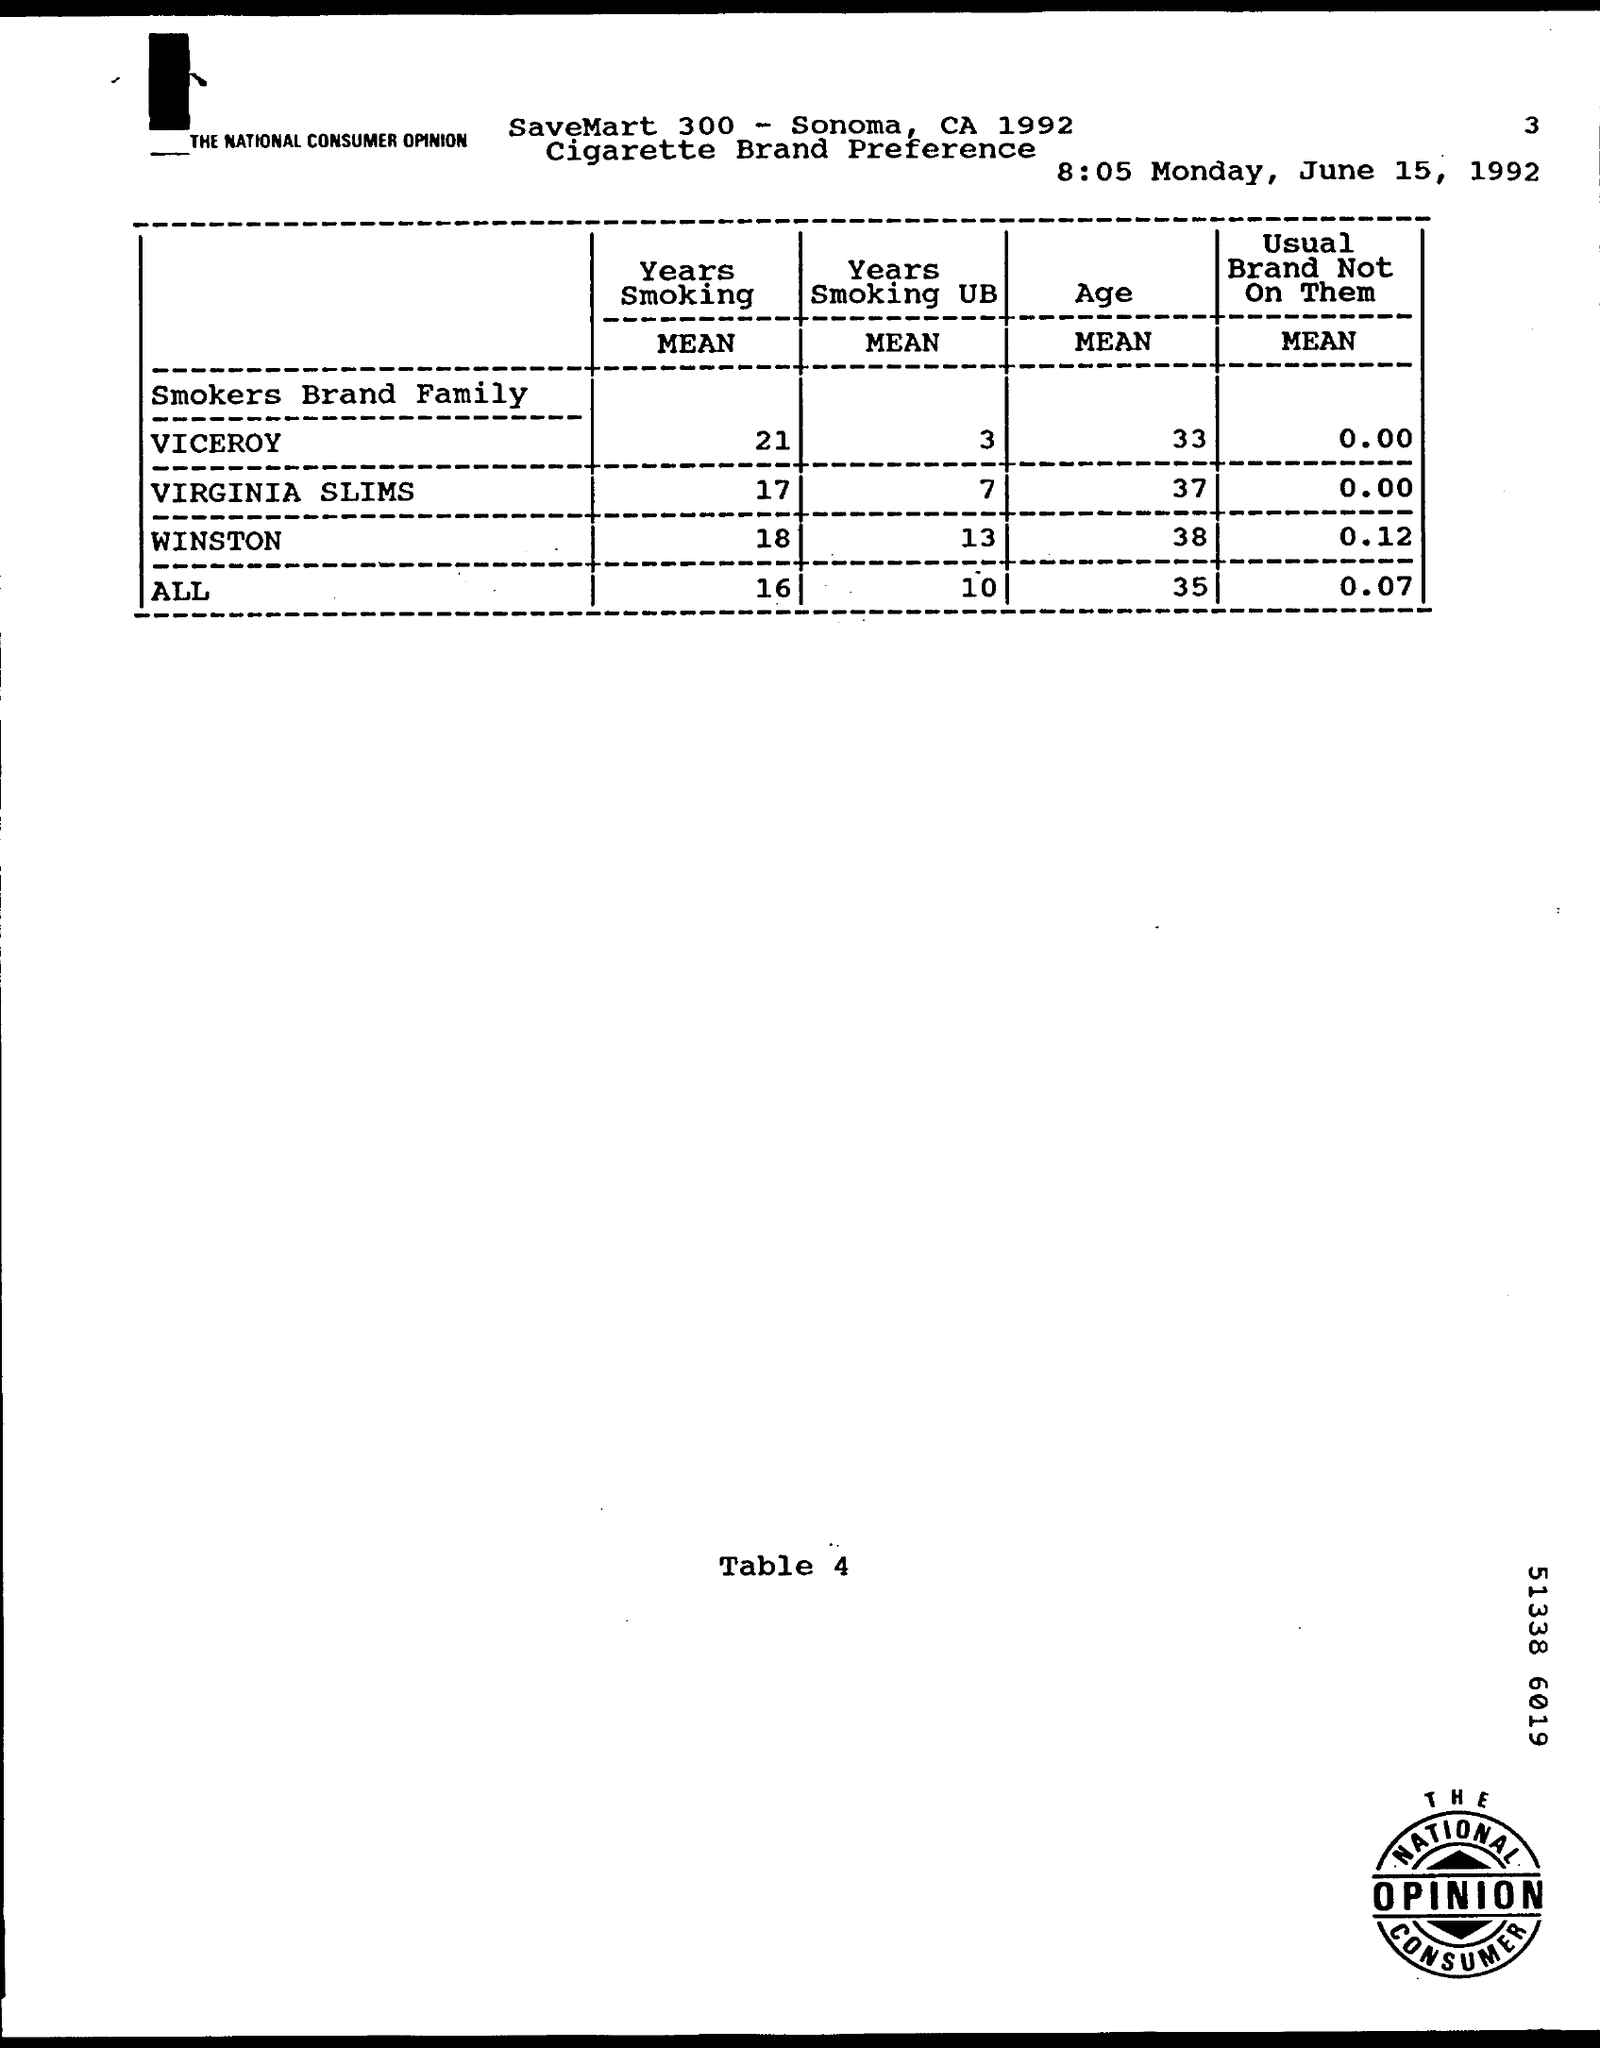What is the mean value of viceroy smokers brand family in the years smoking ?
Make the answer very short. 21. What is the mean value of age in winston smokers brand family ?
Give a very brief answer. 38. What is the mean value age of all smokers brand family ?
Offer a terse response. 35. What is the mean value of virginia slims in the years smoking ub  ?
Your response must be concise. 7. What is the mean value of all smokers brand family of usual brand not on them ?
Your answer should be compact. 0.07. 